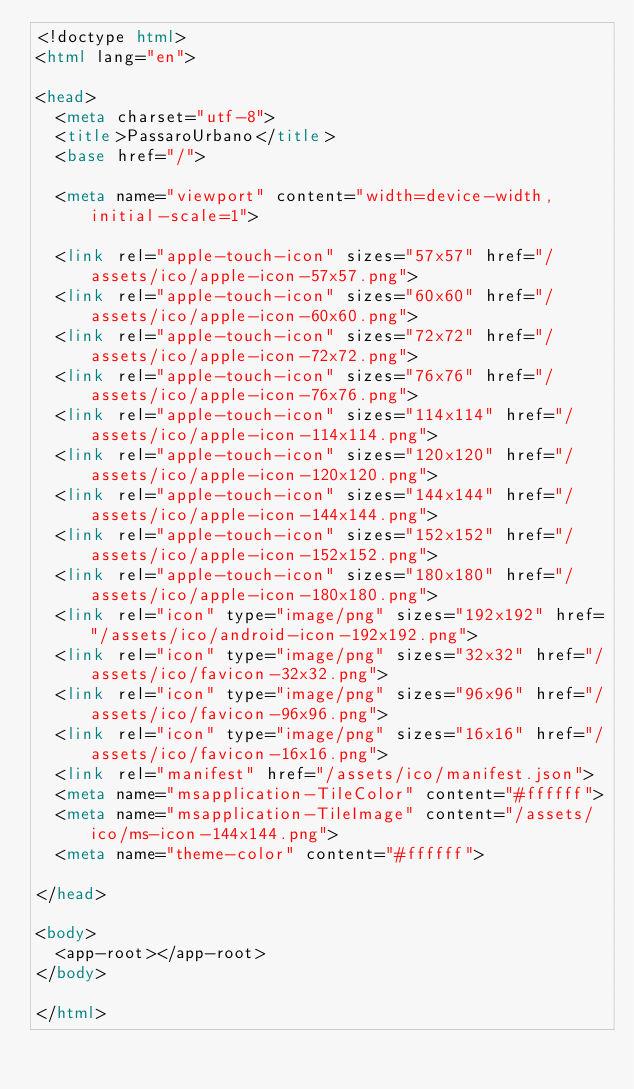<code> <loc_0><loc_0><loc_500><loc_500><_HTML_><!doctype html>
<html lang="en">

<head>
  <meta charset="utf-8">
  <title>PassaroUrbano</title>
  <base href="/">

  <meta name="viewport" content="width=device-width, initial-scale=1">

  <link rel="apple-touch-icon" sizes="57x57" href="/assets/ico/apple-icon-57x57.png">
  <link rel="apple-touch-icon" sizes="60x60" href="/assets/ico/apple-icon-60x60.png">
  <link rel="apple-touch-icon" sizes="72x72" href="/assets/ico/apple-icon-72x72.png">
  <link rel="apple-touch-icon" sizes="76x76" href="/assets/ico/apple-icon-76x76.png">
  <link rel="apple-touch-icon" sizes="114x114" href="/assets/ico/apple-icon-114x114.png">
  <link rel="apple-touch-icon" sizes="120x120" href="/assets/ico/apple-icon-120x120.png">
  <link rel="apple-touch-icon" sizes="144x144" href="/assets/ico/apple-icon-144x144.png">
  <link rel="apple-touch-icon" sizes="152x152" href="/assets/ico/apple-icon-152x152.png">
  <link rel="apple-touch-icon" sizes="180x180" href="/assets/ico/apple-icon-180x180.png">
  <link rel="icon" type="image/png" sizes="192x192" href="/assets/ico/android-icon-192x192.png">
  <link rel="icon" type="image/png" sizes="32x32" href="/assets/ico/favicon-32x32.png">
  <link rel="icon" type="image/png" sizes="96x96" href="/assets/ico/favicon-96x96.png">
  <link rel="icon" type="image/png" sizes="16x16" href="/assets/ico/favicon-16x16.png">
  <link rel="manifest" href="/assets/ico/manifest.json">
  <meta name="msapplication-TileColor" content="#ffffff">
  <meta name="msapplication-TileImage" content="/assets/ico/ms-icon-144x144.png">
  <meta name="theme-color" content="#ffffff">

</head>

<body>
  <app-root></app-root>
</body>

</html></code> 